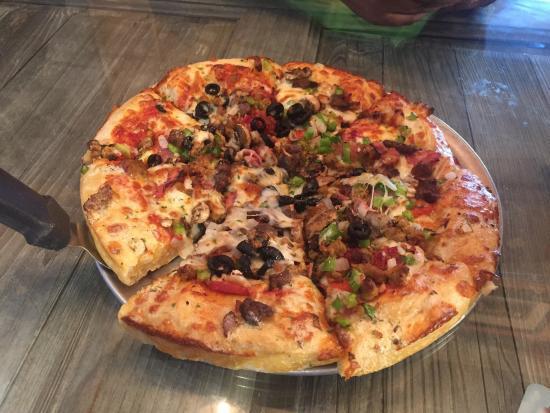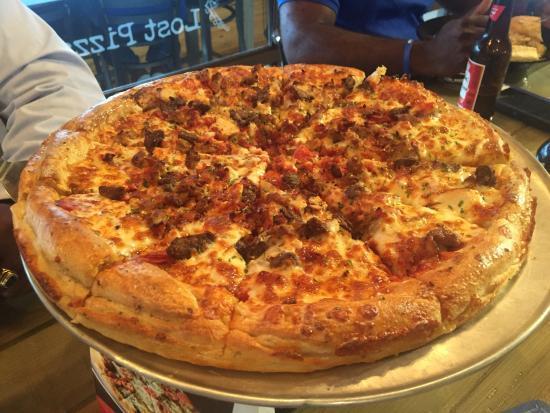The first image is the image on the left, the second image is the image on the right. Examine the images to the left and right. Is the description "No pizza is missing a slice, but the pizza on the left has one slice out of alignment with the rest and is on a silver tray." accurate? Answer yes or no. Yes. 